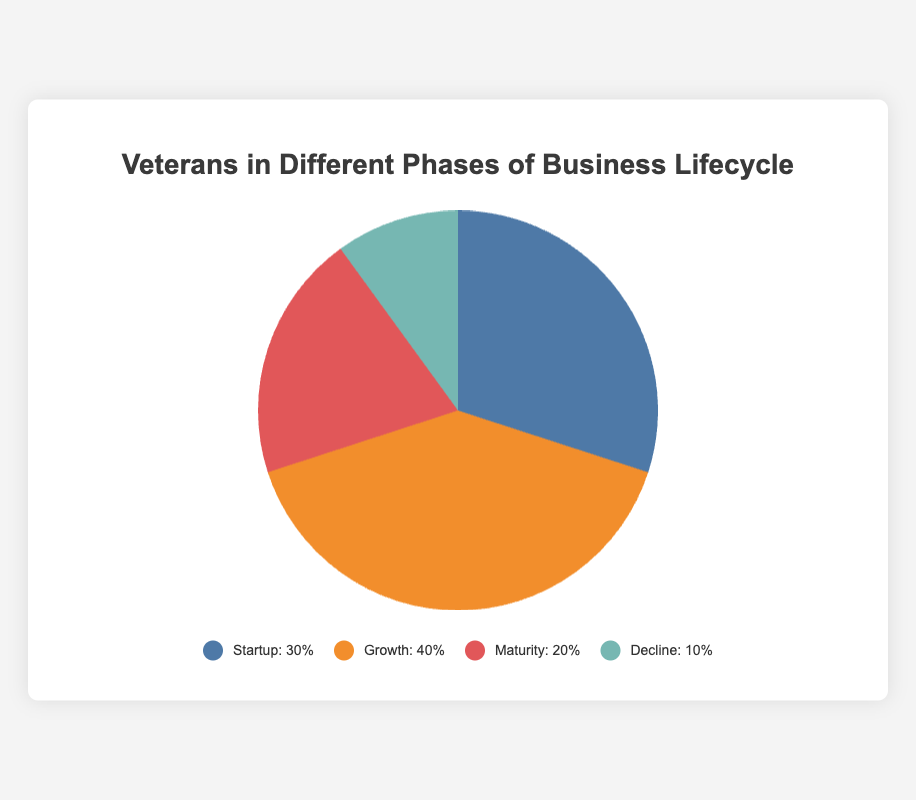What phase has the highest percentage of veteran businesses? To determine the phase with the highest percentage of veteran businesses, we look at the data points in the pie chart where the Growth phase is 40%, which is the largest percentage among all phases.
Answer: Growth What is the combined percentage of veterans in the Startup and Maturity phases? Adding the percentages of the Startup (30%) and Maturity (20%) phases will give us the combined percentage: 30% + 20% = 50%.
Answer: 50% Which phase has the lowest percentage, and what is that percentage? The Decline phase has the lowest percentage, represented as 10% in the pie chart.
Answer: Decline, 10% How much greater is the percentage of veterans in the Growth phase compared to the Maturity phase? Subtracting the percentage of the Maturity phase (20%) from the percentage of the Growth phase (40%) gives: 40% - 20% = 20%.
Answer: 20% What are the colors corresponding to each phase in the pie chart? The colors as shown in the legend are: Startup is blue, Growth is orange, Maturity is red, and Decline is green.
Answer: Startup: blue, Growth: orange, Maturity: red, Decline: green What percentage of veteran businesses are either in the Growth or Decline phases? Adding the percentages of the Growth (40%) and Decline (10%) phases together gives: 40% + 10% = 50%.
Answer: 50% If we combine the Maturity and Decline phases, does their combined percentage exceed that of the Startup phase? Adding the percentages of Maturity (20%) and Decline (10%) gives us 30%. The Startup phase also has 30%, so their combined percentage equals the Startup phase.
Answer: No, it equals By what factor is the percentage of veterans in the Growth phase larger than those in the Decline phase? Dividing the percentage of the Growth phase (40%) by that of the Decline phase (10%) gives: 40% / 10% = 4. Thus, the Growth phase is four times larger than the Decline phase.
Answer: 4 What percentage of veteran businesses are not in the Maturity and Decline phases? To find the percentage of veteran businesses not in the Maturity and Decline phases, subtract the combined percentage of Maturity (20%) and Decline (10%) from 100%: 100% - (20% + 10%) = 70%.
Answer: 70% 